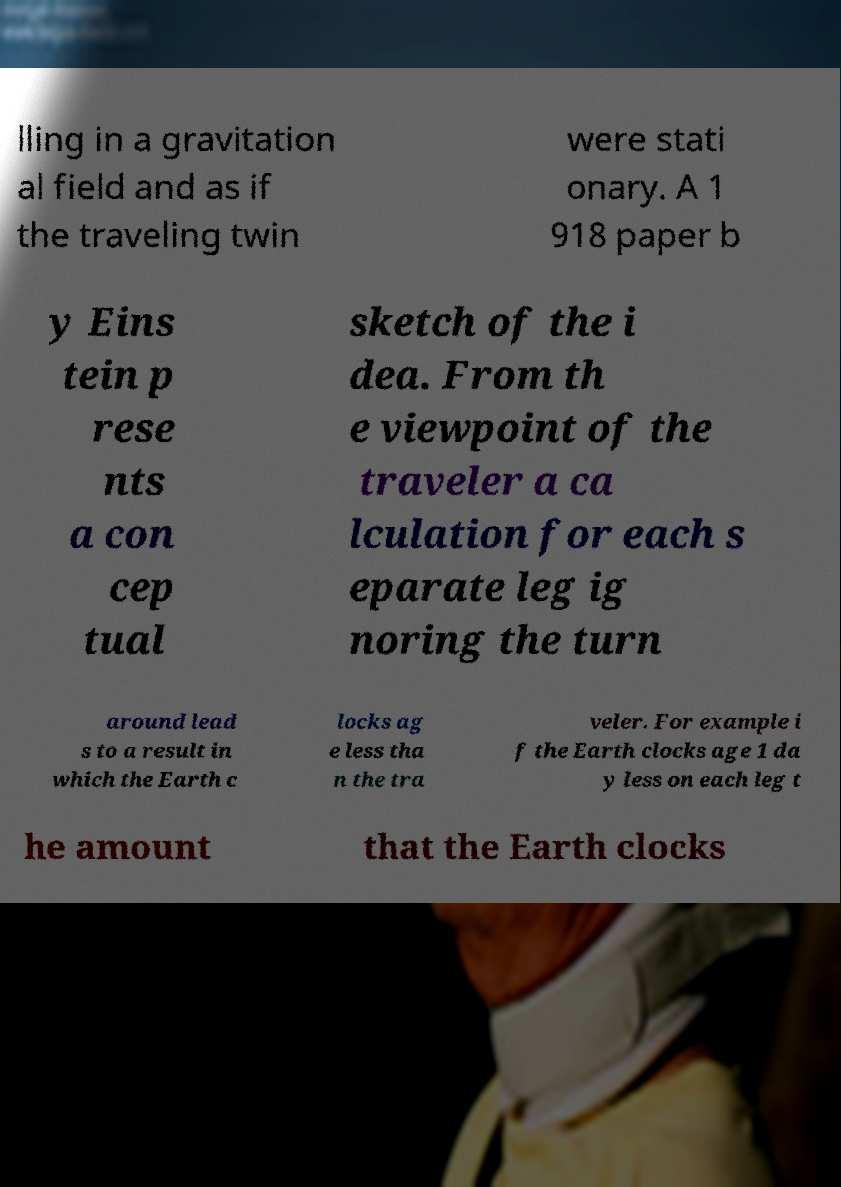Please identify and transcribe the text found in this image. lling in a gravitation al field and as if the traveling twin were stati onary. A 1 918 paper b y Eins tein p rese nts a con cep tual sketch of the i dea. From th e viewpoint of the traveler a ca lculation for each s eparate leg ig noring the turn around lead s to a result in which the Earth c locks ag e less tha n the tra veler. For example i f the Earth clocks age 1 da y less on each leg t he amount that the Earth clocks 